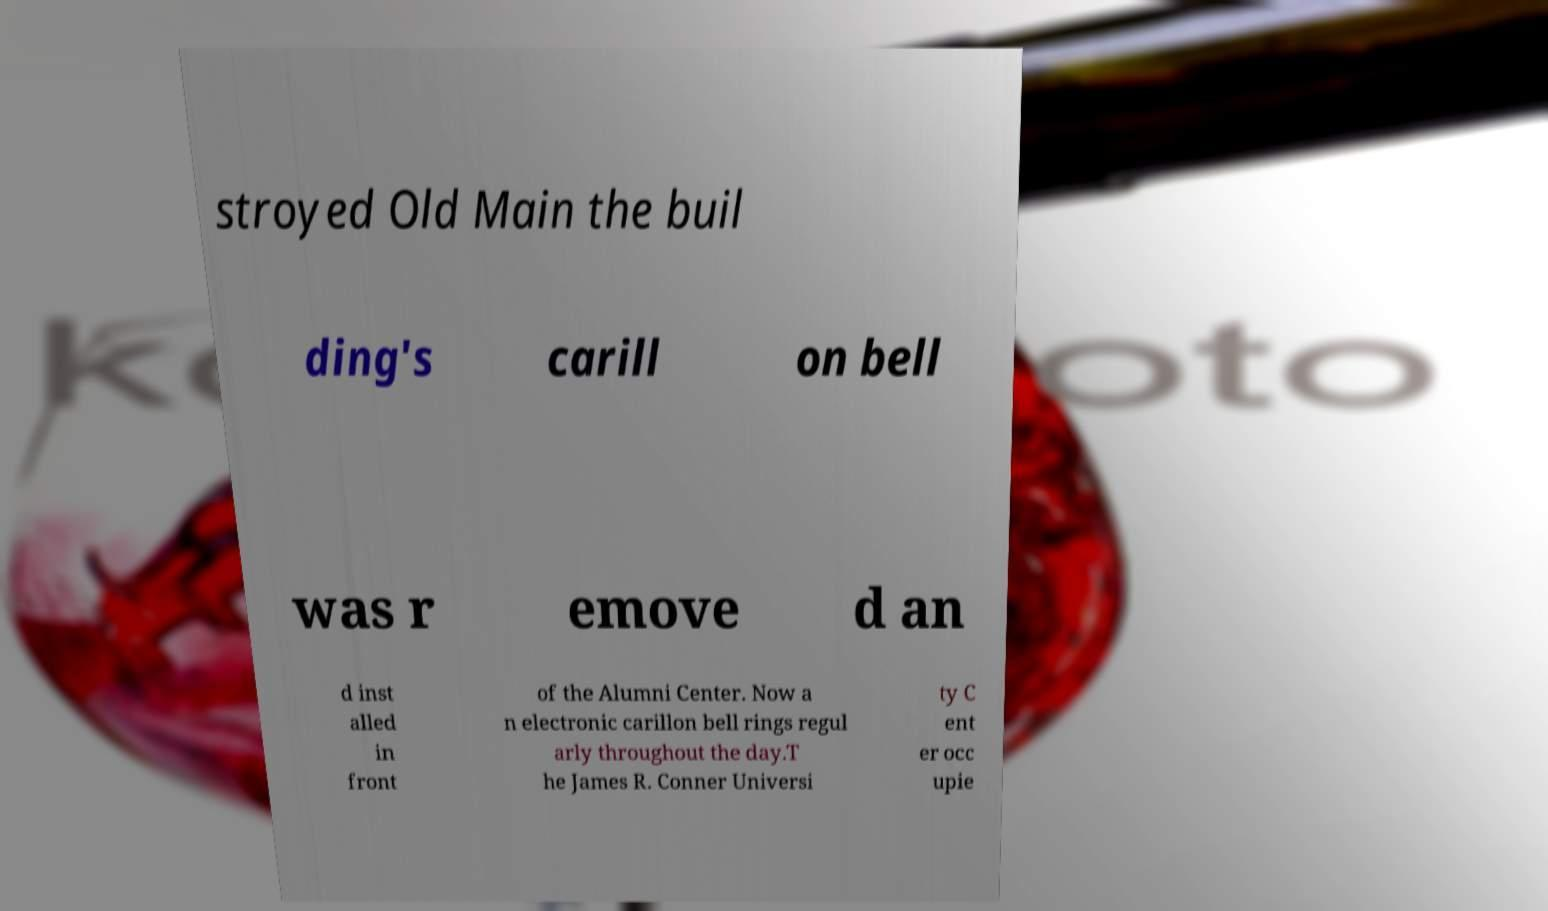Please identify and transcribe the text found in this image. stroyed Old Main the buil ding's carill on bell was r emove d an d inst alled in front of the Alumni Center. Now a n electronic carillon bell rings regul arly throughout the day.T he James R. Conner Universi ty C ent er occ upie 